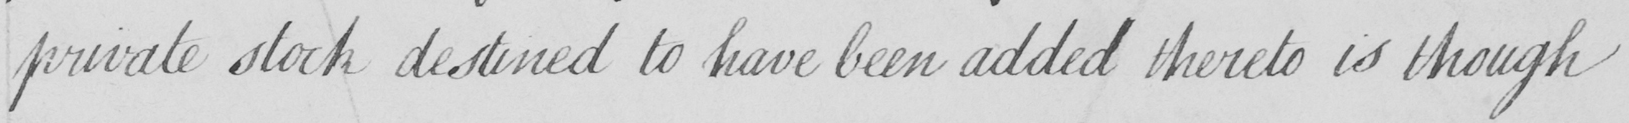What text is written in this handwritten line? private stock destined to have been added thereto is though 